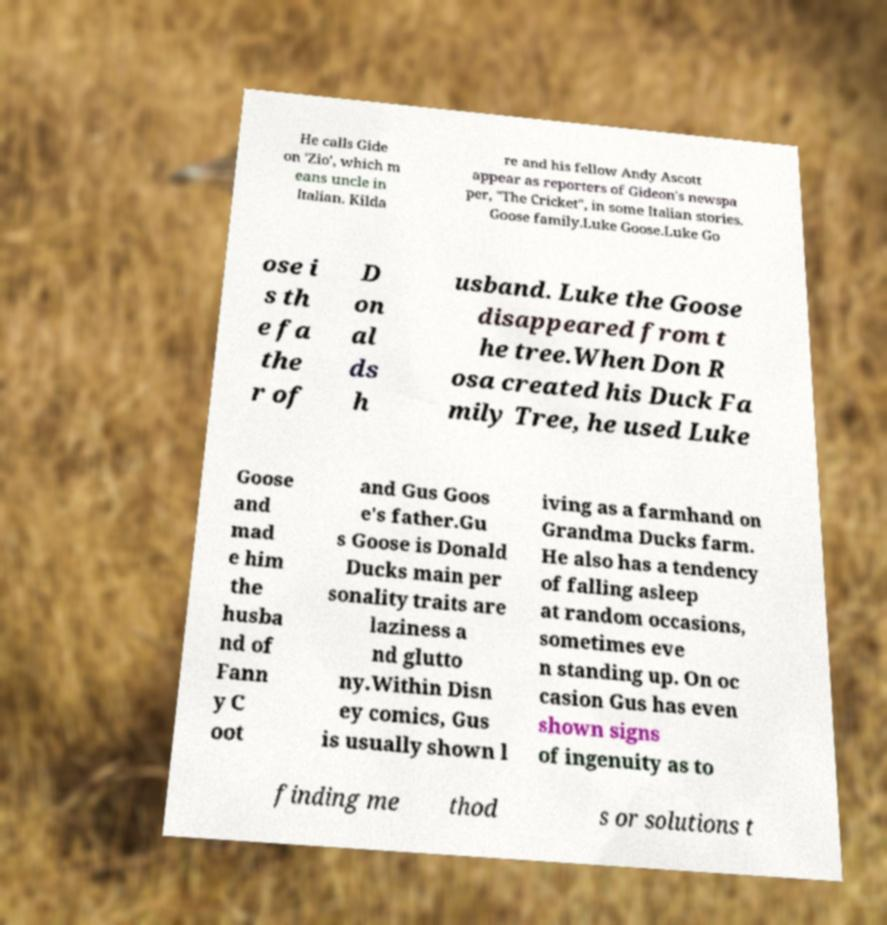Could you extract and type out the text from this image? He calls Gide on 'Zio', which m eans uncle in Italian. Kilda re and his fellow Andy Ascott appear as reporters of Gideon's newspa per, "The Cricket", in some Italian stories. Goose family.Luke Goose.Luke Go ose i s th e fa the r of D on al ds h usband. Luke the Goose disappeared from t he tree.When Don R osa created his Duck Fa mily Tree, he used Luke Goose and mad e him the husba nd of Fann y C oot and Gus Goos e's father.Gu s Goose is Donald Ducks main per sonality traits are laziness a nd glutto ny.Within Disn ey comics, Gus is usually shown l iving as a farmhand on Grandma Ducks farm. He also has a tendency of falling asleep at random occasions, sometimes eve n standing up. On oc casion Gus has even shown signs of ingenuity as to finding me thod s or solutions t 